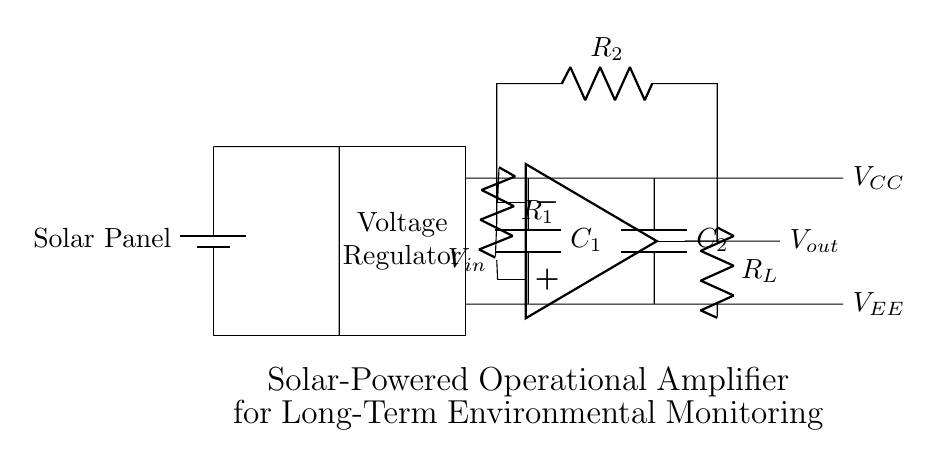What is the main power source for this circuit? The power source is a solar panel, which converts sunlight into electrical energy to power the amplifier.
Answer: Solar Panel What is the role of the voltage regulator? The voltage regulator ensures that the output voltage remains stable and within the required range for the operational amplifier, even as input voltage from the solar panel may vary.
Answer: Voltage Regulator What are the input and output of the operational amplifier labeled as? The input is labeled as V_in and the output as V_out, indicating these are the respective voltage signals that the amplifier processes.
Answer: V_in and V_out How many resistors are present in the input stage of the operational amplifier? There are two resistors, labeled as R1 and R2, which form part of the input circuitry to set gain and input impedance.
Answer: Two What is the purpose of the decoupling capacitors in the circuit? The decoupling capacitors (C1 and C2) stabilize the voltage by filtering out noise and providing a constant charge to the operational amplifier to ensure stable operation.
Answer: Stabilization Which component is essential for performance in low-light conditions? The solar panel is essential, especially under low-light conditions, as it needs to efficiently harvest solar energy to keep the entire circuit powered.
Answer: Solar Panel What is the load resistor labeled as in the circuit? The load resistor is indicated as R_L, which helps control the current flowing through the output of the operational amplifier to connected devices or circuits.
Answer: R_L 